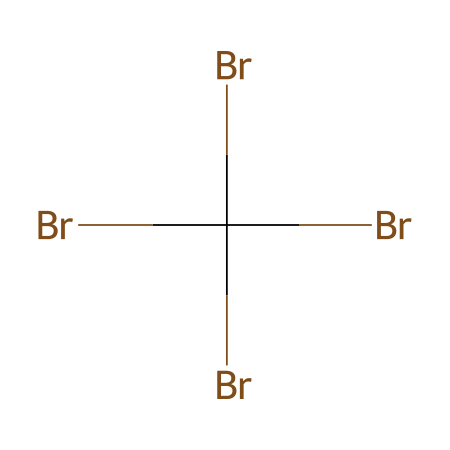What is the total number of bromine atoms in this structure? The SMILES representation shows four bromine atoms represented as 'Br' in the notation. By counting, we see that there are indeed four instances of 'Br'.
Answer: four How many carbon atoms are present in this chemical? The SMILES representation contains one 'C' which indicates there is only one carbon atom in the structure.
Answer: one Is this chemical likely to be a solid, liquid, or gas at room temperature? Given that bromine in various forms is typically a solid or liquid at room temperature due to its halogen nature and the presence of multiple bromine atoms, this chemical is likely to be a solid.
Answer: solid What type of bonding is primarily present in this compound? The presence of multiple bromine-bromine bonds and bromine-carbon bonds suggests that covalent bonding is the primary type of bonding in this structure.
Answer: covalent How does the presence of bromine contribute to flame retardancy in this compound? Bromine's ability to form stable bonds and its high electronegativity often lead to the stabilization of radical species, thus inhibiting combustion and contributing to flame retardancy.
Answer: inhibits combustion What characteristic property of bromine affects the safety messaging in different cultures regarding flame retardants? Bromine is known for its effectiveness as a flame retardant due to its ability to release bromine radicals, which interfere with combustion reactions, making it a focal point of safety messaging across cultures.
Answer: effectiveness as flame retardant 